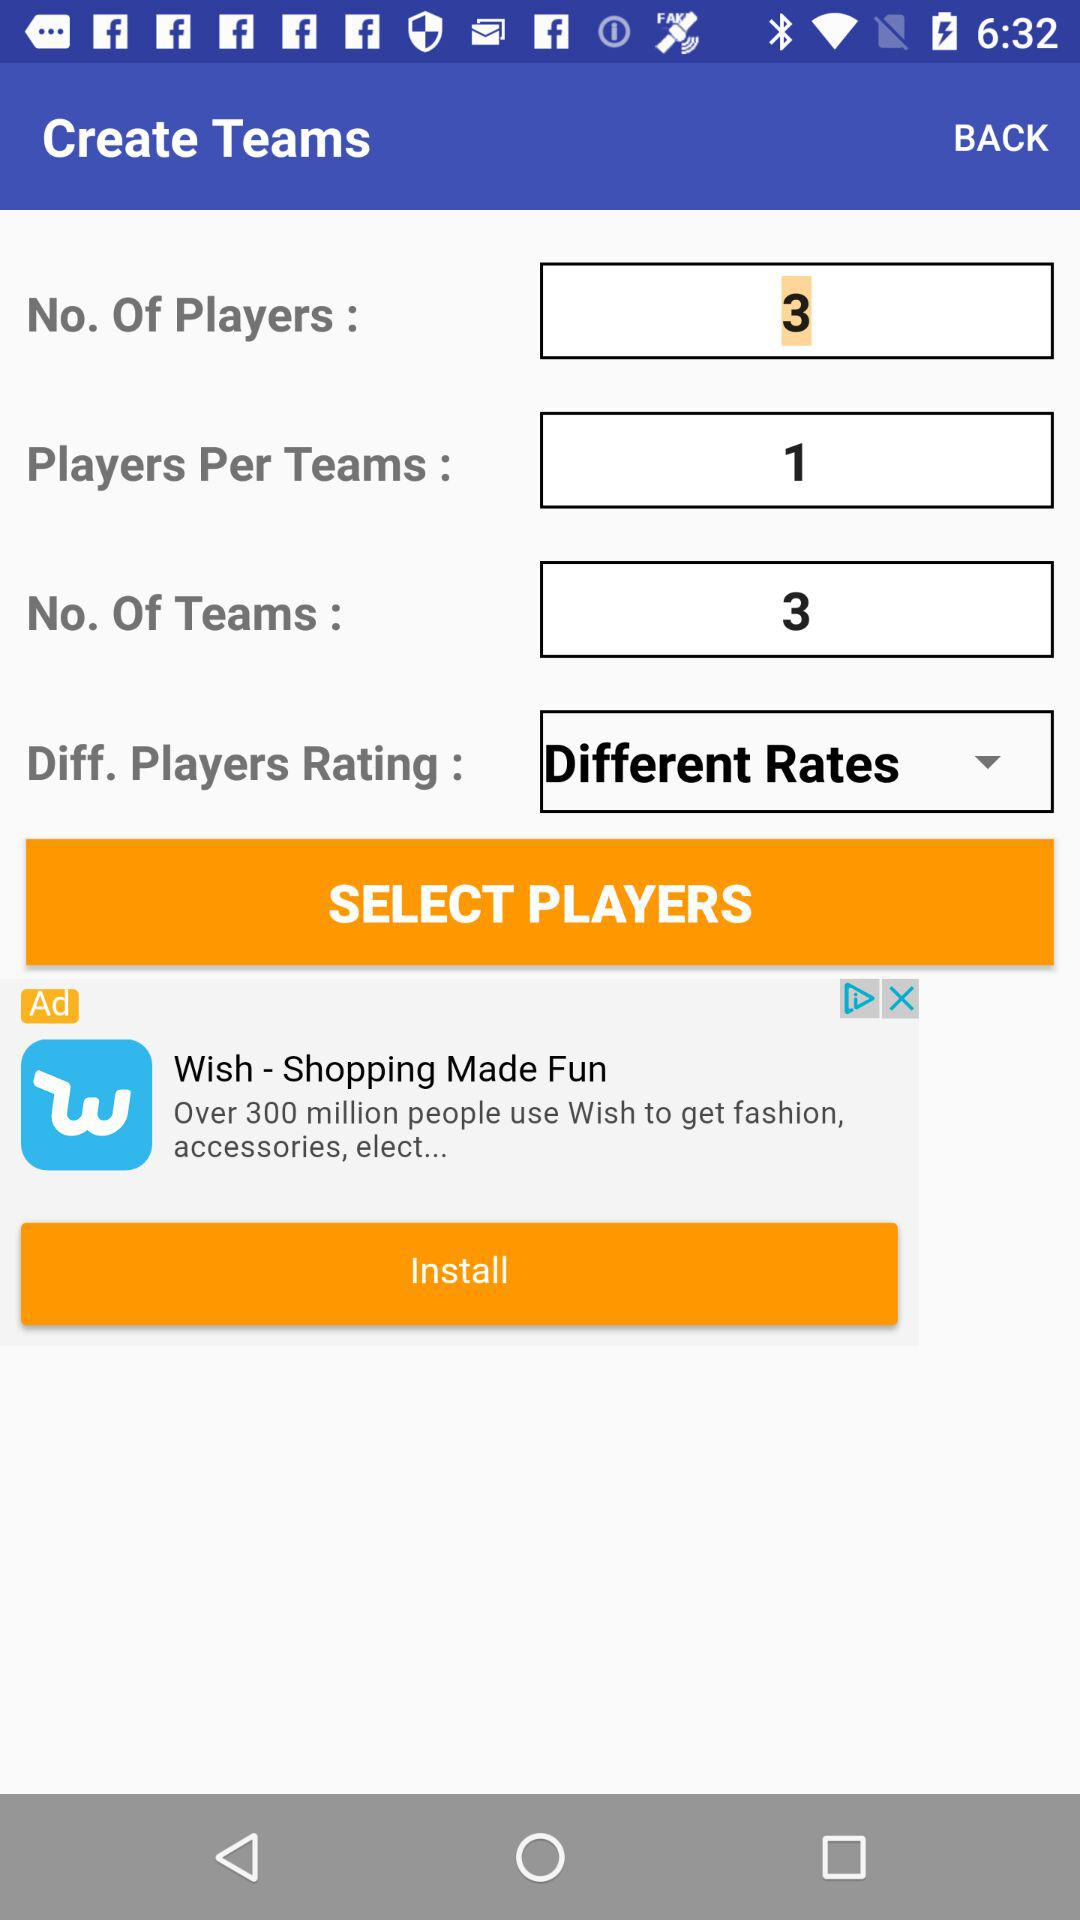What option is selected for "Diff. Players Rating"? The selected option is "Different Rates". 